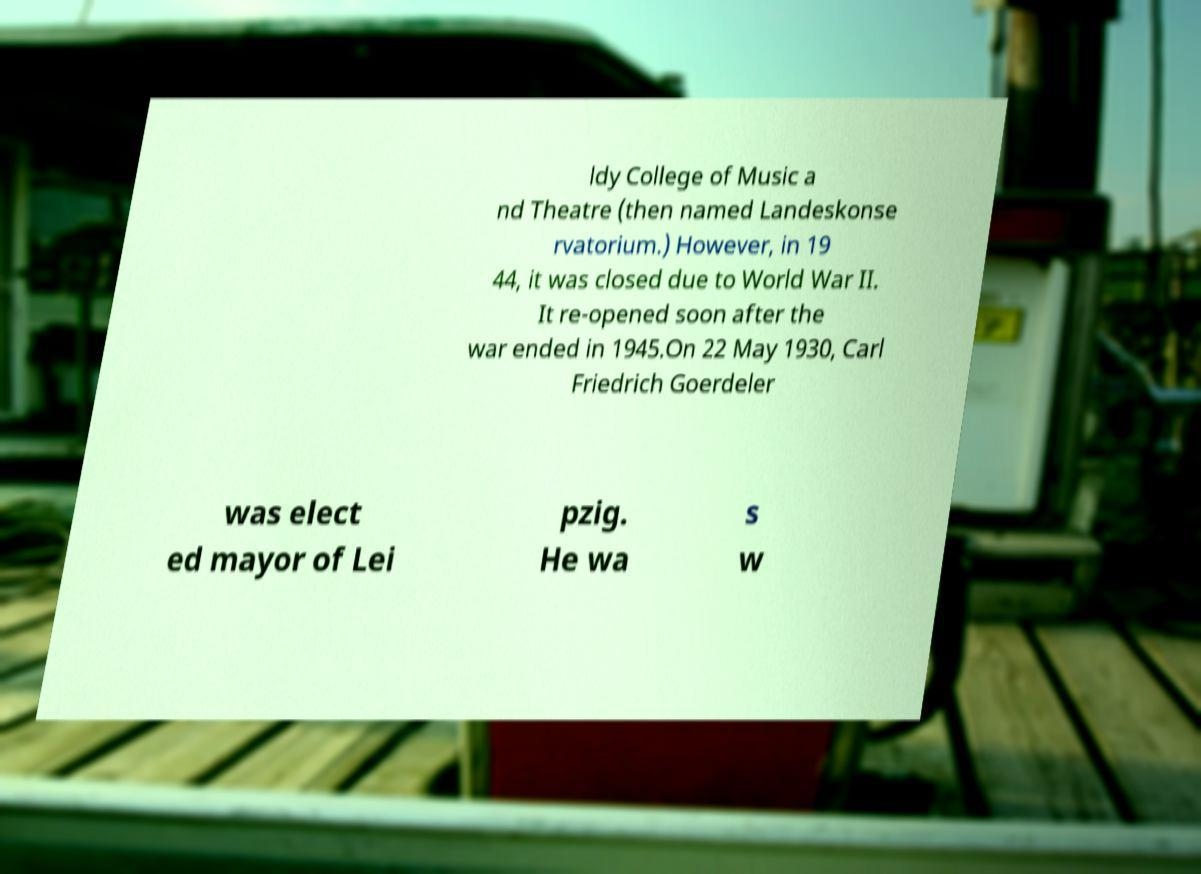Can you accurately transcribe the text from the provided image for me? ldy College of Music a nd Theatre (then named Landeskonse rvatorium.) However, in 19 44, it was closed due to World War II. It re-opened soon after the war ended in 1945.On 22 May 1930, Carl Friedrich Goerdeler was elect ed mayor of Lei pzig. He wa s w 